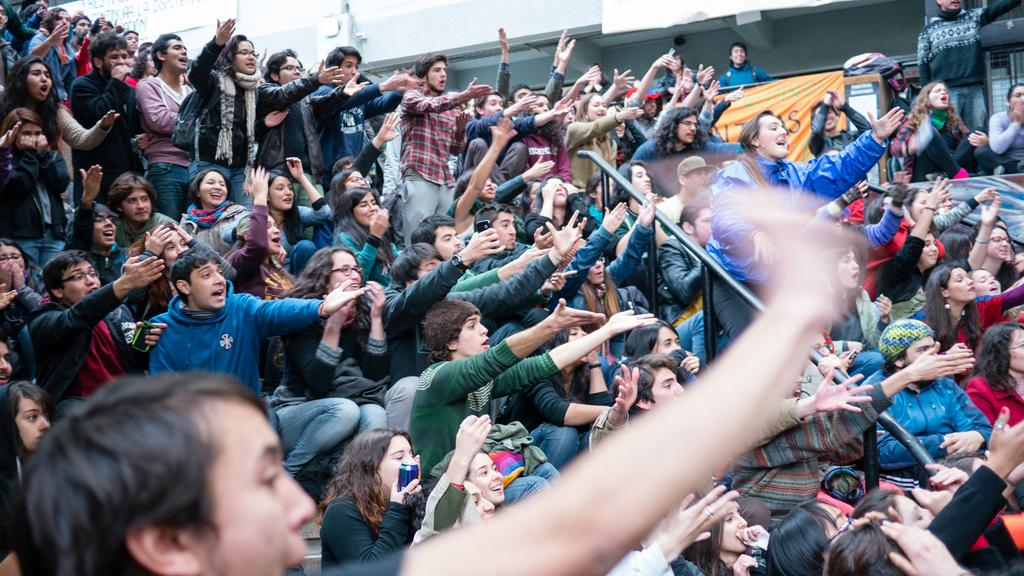How many people are in the image? There is a group of people in the image, but the exact number cannot be determined from the provided facts. What can be seen in the background of the image? There is a banner and other objects visible in the background of the image. What type of clouds can be seen in the image? There is no mention of clouds in the provided facts, so it cannot be determined if any are present in the image. How many toes are visible in the image? There is no mention of toes in the provided facts, so it cannot be determined if any are visible in the image. 